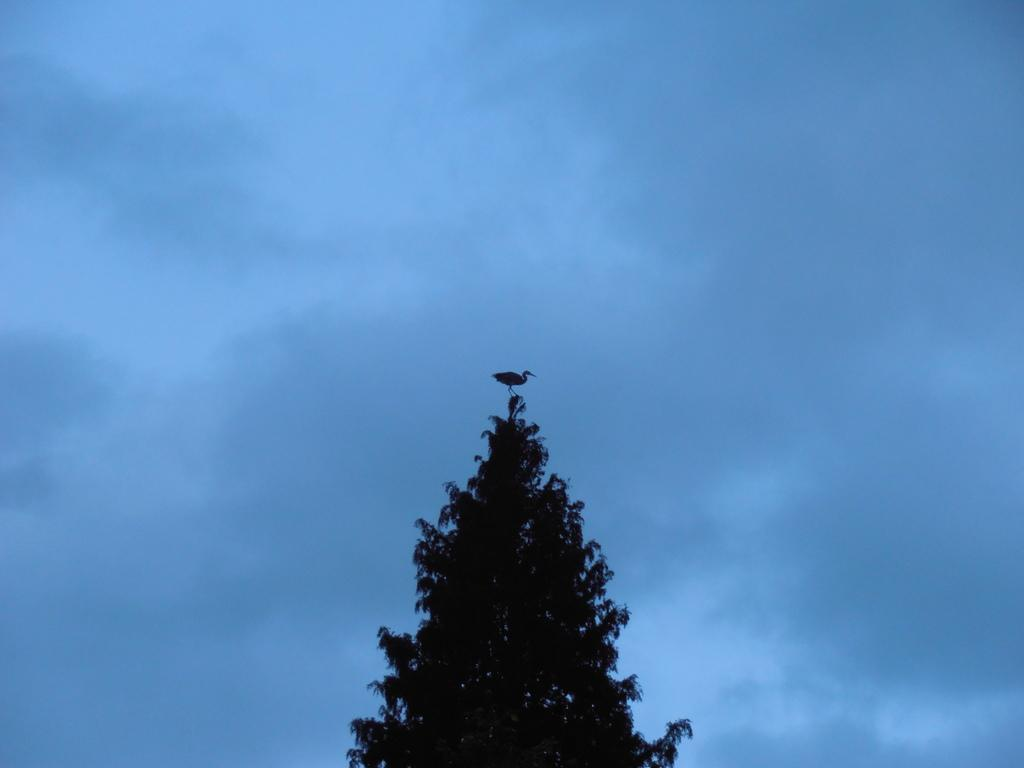What type of animal can be seen in the image? There is a bird in the image. Where is the bird located? The bird is on a tree. What can be seen in the background of the image? The sky is visible in the background of the image. What type of books can be found in the library in the image? There is no library present in the image, as it features a bird on a tree with a visible sky in the background. 